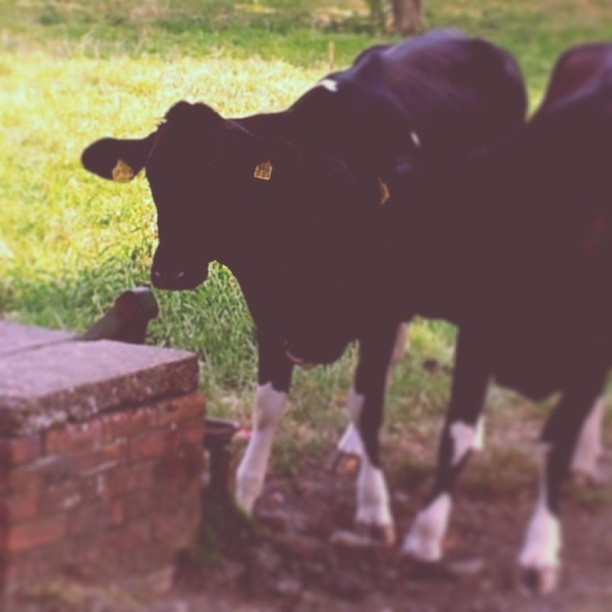Describe the objects in this image and their specific colors. I can see cow in tan, black, purple, brown, and darkgray tones and cow in tan, black, brown, purple, and darkgray tones in this image. 